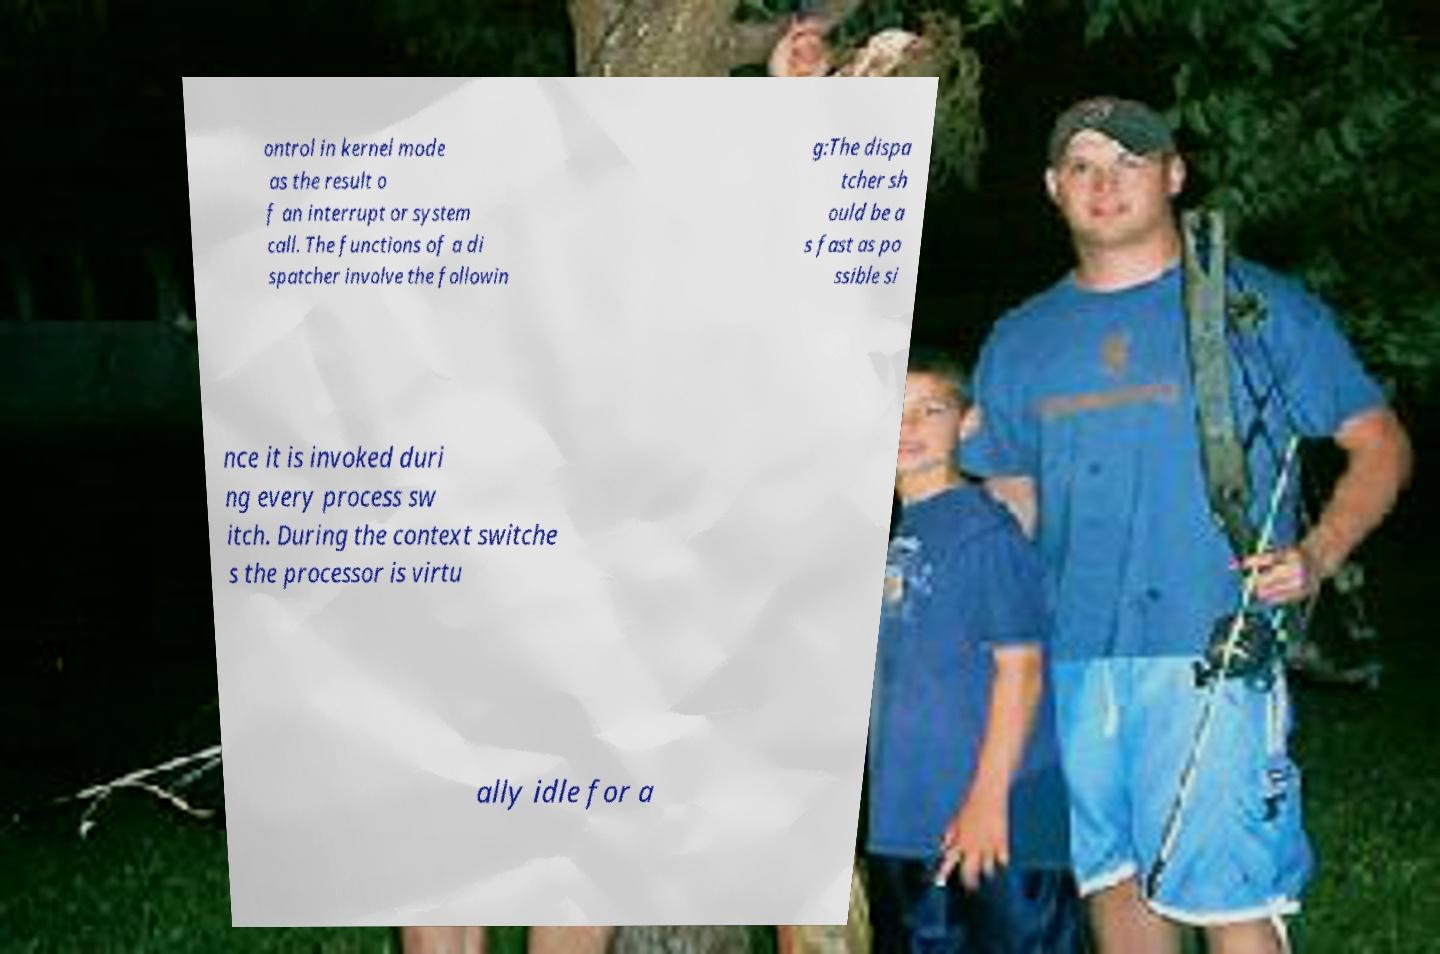There's text embedded in this image that I need extracted. Can you transcribe it verbatim? ontrol in kernel mode as the result o f an interrupt or system call. The functions of a di spatcher involve the followin g:The dispa tcher sh ould be a s fast as po ssible si nce it is invoked duri ng every process sw itch. During the context switche s the processor is virtu ally idle for a 